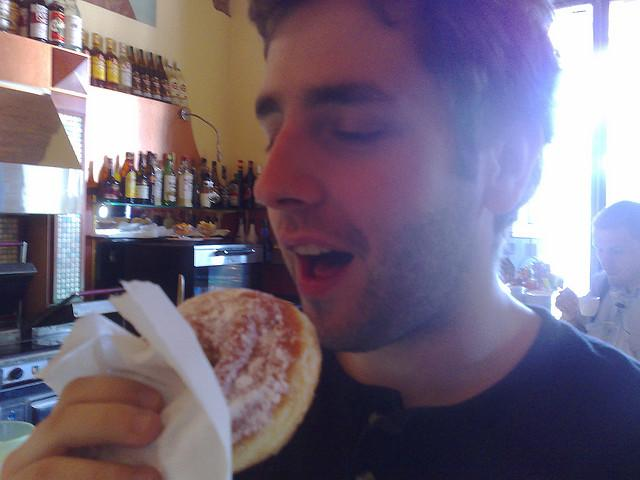How was the item prepared that is about to be bitten? fried 